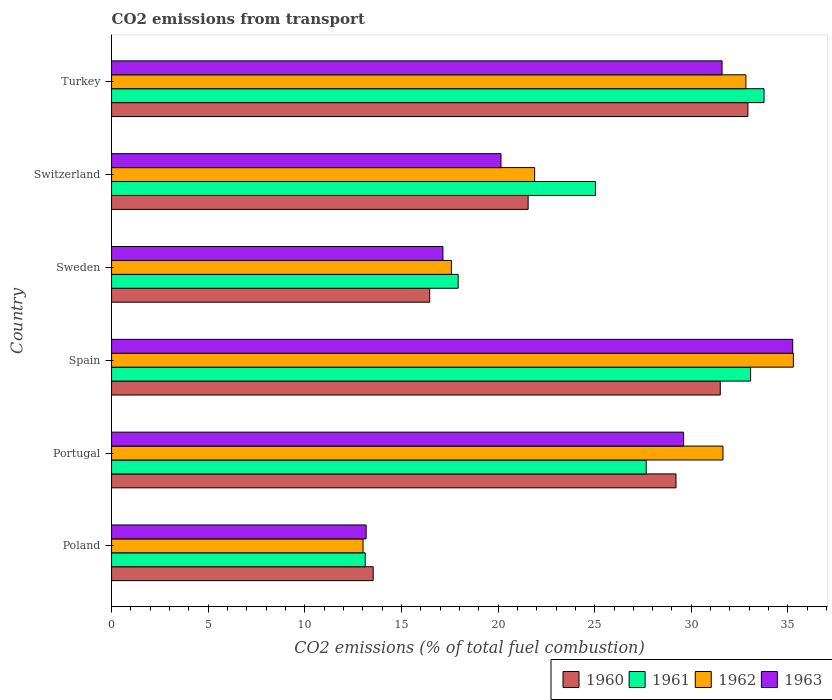How many different coloured bars are there?
Offer a very short reply. 4. Are the number of bars per tick equal to the number of legend labels?
Make the answer very short. Yes. Are the number of bars on each tick of the Y-axis equal?
Your answer should be compact. Yes. How many bars are there on the 2nd tick from the bottom?
Provide a succinct answer. 4. What is the label of the 4th group of bars from the top?
Offer a very short reply. Spain. What is the total CO2 emitted in 1960 in Sweden?
Give a very brief answer. 16.46. Across all countries, what is the maximum total CO2 emitted in 1962?
Your answer should be compact. 35.28. Across all countries, what is the minimum total CO2 emitted in 1961?
Provide a short and direct response. 13.13. What is the total total CO2 emitted in 1963 in the graph?
Give a very brief answer. 146.91. What is the difference between the total CO2 emitted in 1963 in Poland and that in Switzerland?
Your answer should be compact. -6.98. What is the difference between the total CO2 emitted in 1962 in Poland and the total CO2 emitted in 1960 in Turkey?
Provide a succinct answer. -19.91. What is the average total CO2 emitted in 1961 per country?
Your answer should be very brief. 25.1. What is the difference between the total CO2 emitted in 1961 and total CO2 emitted in 1962 in Sweden?
Make the answer very short. 0.35. In how many countries, is the total CO2 emitted in 1963 greater than 21 ?
Make the answer very short. 3. What is the ratio of the total CO2 emitted in 1961 in Poland to that in Portugal?
Provide a short and direct response. 0.47. Is the difference between the total CO2 emitted in 1961 in Portugal and Turkey greater than the difference between the total CO2 emitted in 1962 in Portugal and Turkey?
Provide a succinct answer. No. What is the difference between the highest and the second highest total CO2 emitted in 1963?
Give a very brief answer. 3.66. What is the difference between the highest and the lowest total CO2 emitted in 1960?
Provide a short and direct response. 19.39. Is the sum of the total CO2 emitted in 1960 in Poland and Portugal greater than the maximum total CO2 emitted in 1961 across all countries?
Keep it short and to the point. Yes. Is it the case that in every country, the sum of the total CO2 emitted in 1962 and total CO2 emitted in 1961 is greater than the sum of total CO2 emitted in 1963 and total CO2 emitted in 1960?
Offer a terse response. No. What does the 4th bar from the bottom in Spain represents?
Provide a short and direct response. 1963. Is it the case that in every country, the sum of the total CO2 emitted in 1963 and total CO2 emitted in 1961 is greater than the total CO2 emitted in 1962?
Your answer should be very brief. Yes. Are all the bars in the graph horizontal?
Offer a very short reply. Yes. How many countries are there in the graph?
Keep it short and to the point. 6. Does the graph contain any zero values?
Give a very brief answer. No. Where does the legend appear in the graph?
Give a very brief answer. Bottom right. How many legend labels are there?
Provide a short and direct response. 4. What is the title of the graph?
Ensure brevity in your answer.  CO2 emissions from transport. What is the label or title of the X-axis?
Offer a very short reply. CO2 emissions (% of total fuel combustion). What is the label or title of the Y-axis?
Keep it short and to the point. Country. What is the CO2 emissions (% of total fuel combustion) of 1960 in Poland?
Provide a succinct answer. 13.54. What is the CO2 emissions (% of total fuel combustion) of 1961 in Poland?
Make the answer very short. 13.13. What is the CO2 emissions (% of total fuel combustion) of 1962 in Poland?
Provide a succinct answer. 13.01. What is the CO2 emissions (% of total fuel combustion) in 1963 in Poland?
Provide a short and direct response. 13.17. What is the CO2 emissions (% of total fuel combustion) in 1960 in Portugal?
Give a very brief answer. 29.21. What is the CO2 emissions (% of total fuel combustion) of 1961 in Portugal?
Give a very brief answer. 27.67. What is the CO2 emissions (% of total fuel combustion) of 1962 in Portugal?
Provide a succinct answer. 31.64. What is the CO2 emissions (% of total fuel combustion) in 1963 in Portugal?
Provide a short and direct response. 29.6. What is the CO2 emissions (% of total fuel combustion) of 1960 in Spain?
Ensure brevity in your answer.  31.5. What is the CO2 emissions (% of total fuel combustion) of 1961 in Spain?
Offer a very short reply. 33.07. What is the CO2 emissions (% of total fuel combustion) in 1962 in Spain?
Provide a short and direct response. 35.28. What is the CO2 emissions (% of total fuel combustion) in 1963 in Spain?
Offer a very short reply. 35.25. What is the CO2 emissions (% of total fuel combustion) of 1960 in Sweden?
Your response must be concise. 16.46. What is the CO2 emissions (% of total fuel combustion) in 1961 in Sweden?
Make the answer very short. 17.94. What is the CO2 emissions (% of total fuel combustion) in 1962 in Sweden?
Your answer should be compact. 17.59. What is the CO2 emissions (% of total fuel combustion) of 1963 in Sweden?
Make the answer very short. 17.15. What is the CO2 emissions (% of total fuel combustion) in 1960 in Switzerland?
Give a very brief answer. 21.56. What is the CO2 emissions (% of total fuel combustion) in 1961 in Switzerland?
Provide a short and direct response. 25.04. What is the CO2 emissions (% of total fuel combustion) of 1962 in Switzerland?
Provide a succinct answer. 21.89. What is the CO2 emissions (% of total fuel combustion) of 1963 in Switzerland?
Make the answer very short. 20.15. What is the CO2 emissions (% of total fuel combustion) in 1960 in Turkey?
Provide a short and direct response. 32.93. What is the CO2 emissions (% of total fuel combustion) in 1961 in Turkey?
Make the answer very short. 33.76. What is the CO2 emissions (% of total fuel combustion) in 1962 in Turkey?
Provide a short and direct response. 32.82. What is the CO2 emissions (% of total fuel combustion) in 1963 in Turkey?
Give a very brief answer. 31.59. Across all countries, what is the maximum CO2 emissions (% of total fuel combustion) of 1960?
Offer a terse response. 32.93. Across all countries, what is the maximum CO2 emissions (% of total fuel combustion) of 1961?
Provide a succinct answer. 33.76. Across all countries, what is the maximum CO2 emissions (% of total fuel combustion) of 1962?
Make the answer very short. 35.28. Across all countries, what is the maximum CO2 emissions (% of total fuel combustion) in 1963?
Provide a short and direct response. 35.25. Across all countries, what is the minimum CO2 emissions (% of total fuel combustion) of 1960?
Your answer should be compact. 13.54. Across all countries, what is the minimum CO2 emissions (% of total fuel combustion) of 1961?
Give a very brief answer. 13.13. Across all countries, what is the minimum CO2 emissions (% of total fuel combustion) in 1962?
Your answer should be very brief. 13.01. Across all countries, what is the minimum CO2 emissions (% of total fuel combustion) in 1963?
Your answer should be very brief. 13.17. What is the total CO2 emissions (% of total fuel combustion) in 1960 in the graph?
Offer a very short reply. 145.19. What is the total CO2 emissions (% of total fuel combustion) of 1961 in the graph?
Give a very brief answer. 150.6. What is the total CO2 emissions (% of total fuel combustion) in 1962 in the graph?
Provide a succinct answer. 152.24. What is the total CO2 emissions (% of total fuel combustion) of 1963 in the graph?
Your answer should be very brief. 146.91. What is the difference between the CO2 emissions (% of total fuel combustion) in 1960 in Poland and that in Portugal?
Your response must be concise. -15.67. What is the difference between the CO2 emissions (% of total fuel combustion) of 1961 in Poland and that in Portugal?
Ensure brevity in your answer.  -14.54. What is the difference between the CO2 emissions (% of total fuel combustion) of 1962 in Poland and that in Portugal?
Provide a succinct answer. -18.62. What is the difference between the CO2 emissions (% of total fuel combustion) of 1963 in Poland and that in Portugal?
Make the answer very short. -16.43. What is the difference between the CO2 emissions (% of total fuel combustion) in 1960 in Poland and that in Spain?
Give a very brief answer. -17.96. What is the difference between the CO2 emissions (% of total fuel combustion) in 1961 in Poland and that in Spain?
Provide a short and direct response. -19.94. What is the difference between the CO2 emissions (% of total fuel combustion) in 1962 in Poland and that in Spain?
Your answer should be very brief. -22.27. What is the difference between the CO2 emissions (% of total fuel combustion) in 1963 in Poland and that in Spain?
Your answer should be compact. -22.07. What is the difference between the CO2 emissions (% of total fuel combustion) in 1960 in Poland and that in Sweden?
Your response must be concise. -2.92. What is the difference between the CO2 emissions (% of total fuel combustion) in 1961 in Poland and that in Sweden?
Keep it short and to the point. -4.81. What is the difference between the CO2 emissions (% of total fuel combustion) of 1962 in Poland and that in Sweden?
Give a very brief answer. -4.57. What is the difference between the CO2 emissions (% of total fuel combustion) of 1963 in Poland and that in Sweden?
Offer a very short reply. -3.97. What is the difference between the CO2 emissions (% of total fuel combustion) in 1960 in Poland and that in Switzerland?
Ensure brevity in your answer.  -8.02. What is the difference between the CO2 emissions (% of total fuel combustion) of 1961 in Poland and that in Switzerland?
Ensure brevity in your answer.  -11.91. What is the difference between the CO2 emissions (% of total fuel combustion) of 1962 in Poland and that in Switzerland?
Your answer should be compact. -8.88. What is the difference between the CO2 emissions (% of total fuel combustion) in 1963 in Poland and that in Switzerland?
Make the answer very short. -6.98. What is the difference between the CO2 emissions (% of total fuel combustion) of 1960 in Poland and that in Turkey?
Give a very brief answer. -19.39. What is the difference between the CO2 emissions (% of total fuel combustion) in 1961 in Poland and that in Turkey?
Keep it short and to the point. -20.64. What is the difference between the CO2 emissions (% of total fuel combustion) in 1962 in Poland and that in Turkey?
Provide a short and direct response. -19.81. What is the difference between the CO2 emissions (% of total fuel combustion) of 1963 in Poland and that in Turkey?
Offer a very short reply. -18.42. What is the difference between the CO2 emissions (% of total fuel combustion) in 1960 in Portugal and that in Spain?
Your answer should be compact. -2.29. What is the difference between the CO2 emissions (% of total fuel combustion) in 1961 in Portugal and that in Spain?
Your answer should be compact. -5.4. What is the difference between the CO2 emissions (% of total fuel combustion) of 1962 in Portugal and that in Spain?
Keep it short and to the point. -3.64. What is the difference between the CO2 emissions (% of total fuel combustion) in 1963 in Portugal and that in Spain?
Offer a very short reply. -5.65. What is the difference between the CO2 emissions (% of total fuel combustion) of 1960 in Portugal and that in Sweden?
Your response must be concise. 12.75. What is the difference between the CO2 emissions (% of total fuel combustion) of 1961 in Portugal and that in Sweden?
Keep it short and to the point. 9.73. What is the difference between the CO2 emissions (% of total fuel combustion) in 1962 in Portugal and that in Sweden?
Offer a very short reply. 14.05. What is the difference between the CO2 emissions (% of total fuel combustion) of 1963 in Portugal and that in Sweden?
Make the answer very short. 12.45. What is the difference between the CO2 emissions (% of total fuel combustion) of 1960 in Portugal and that in Switzerland?
Provide a succinct answer. 7.65. What is the difference between the CO2 emissions (% of total fuel combustion) in 1961 in Portugal and that in Switzerland?
Offer a very short reply. 2.62. What is the difference between the CO2 emissions (% of total fuel combustion) of 1962 in Portugal and that in Switzerland?
Provide a succinct answer. 9.75. What is the difference between the CO2 emissions (% of total fuel combustion) in 1963 in Portugal and that in Switzerland?
Give a very brief answer. 9.45. What is the difference between the CO2 emissions (% of total fuel combustion) in 1960 in Portugal and that in Turkey?
Your answer should be compact. -3.72. What is the difference between the CO2 emissions (% of total fuel combustion) in 1961 in Portugal and that in Turkey?
Keep it short and to the point. -6.1. What is the difference between the CO2 emissions (% of total fuel combustion) in 1962 in Portugal and that in Turkey?
Make the answer very short. -1.19. What is the difference between the CO2 emissions (% of total fuel combustion) in 1963 in Portugal and that in Turkey?
Provide a short and direct response. -1.99. What is the difference between the CO2 emissions (% of total fuel combustion) of 1960 in Spain and that in Sweden?
Provide a succinct answer. 15.04. What is the difference between the CO2 emissions (% of total fuel combustion) of 1961 in Spain and that in Sweden?
Offer a very short reply. 15.13. What is the difference between the CO2 emissions (% of total fuel combustion) in 1962 in Spain and that in Sweden?
Your response must be concise. 17.7. What is the difference between the CO2 emissions (% of total fuel combustion) of 1963 in Spain and that in Sweden?
Provide a short and direct response. 18.1. What is the difference between the CO2 emissions (% of total fuel combustion) in 1960 in Spain and that in Switzerland?
Keep it short and to the point. 9.94. What is the difference between the CO2 emissions (% of total fuel combustion) of 1961 in Spain and that in Switzerland?
Offer a very short reply. 8.03. What is the difference between the CO2 emissions (% of total fuel combustion) of 1962 in Spain and that in Switzerland?
Keep it short and to the point. 13.39. What is the difference between the CO2 emissions (% of total fuel combustion) of 1963 in Spain and that in Switzerland?
Your answer should be compact. 15.1. What is the difference between the CO2 emissions (% of total fuel combustion) of 1960 in Spain and that in Turkey?
Your answer should be compact. -1.43. What is the difference between the CO2 emissions (% of total fuel combustion) in 1961 in Spain and that in Turkey?
Offer a terse response. -0.7. What is the difference between the CO2 emissions (% of total fuel combustion) of 1962 in Spain and that in Turkey?
Keep it short and to the point. 2.46. What is the difference between the CO2 emissions (% of total fuel combustion) in 1963 in Spain and that in Turkey?
Offer a very short reply. 3.66. What is the difference between the CO2 emissions (% of total fuel combustion) in 1960 in Sweden and that in Switzerland?
Provide a short and direct response. -5.09. What is the difference between the CO2 emissions (% of total fuel combustion) of 1961 in Sweden and that in Switzerland?
Give a very brief answer. -7.1. What is the difference between the CO2 emissions (% of total fuel combustion) of 1962 in Sweden and that in Switzerland?
Ensure brevity in your answer.  -4.31. What is the difference between the CO2 emissions (% of total fuel combustion) in 1963 in Sweden and that in Switzerland?
Provide a succinct answer. -3.01. What is the difference between the CO2 emissions (% of total fuel combustion) of 1960 in Sweden and that in Turkey?
Provide a short and direct response. -16.47. What is the difference between the CO2 emissions (% of total fuel combustion) of 1961 in Sweden and that in Turkey?
Your answer should be very brief. -15.83. What is the difference between the CO2 emissions (% of total fuel combustion) of 1962 in Sweden and that in Turkey?
Your response must be concise. -15.24. What is the difference between the CO2 emissions (% of total fuel combustion) in 1963 in Sweden and that in Turkey?
Ensure brevity in your answer.  -14.44. What is the difference between the CO2 emissions (% of total fuel combustion) of 1960 in Switzerland and that in Turkey?
Your answer should be very brief. -11.37. What is the difference between the CO2 emissions (% of total fuel combustion) of 1961 in Switzerland and that in Turkey?
Provide a succinct answer. -8.72. What is the difference between the CO2 emissions (% of total fuel combustion) in 1962 in Switzerland and that in Turkey?
Ensure brevity in your answer.  -10.93. What is the difference between the CO2 emissions (% of total fuel combustion) of 1963 in Switzerland and that in Turkey?
Provide a succinct answer. -11.44. What is the difference between the CO2 emissions (% of total fuel combustion) of 1960 in Poland and the CO2 emissions (% of total fuel combustion) of 1961 in Portugal?
Provide a succinct answer. -14.13. What is the difference between the CO2 emissions (% of total fuel combustion) of 1960 in Poland and the CO2 emissions (% of total fuel combustion) of 1962 in Portugal?
Your answer should be very brief. -18.1. What is the difference between the CO2 emissions (% of total fuel combustion) in 1960 in Poland and the CO2 emissions (% of total fuel combustion) in 1963 in Portugal?
Keep it short and to the point. -16.06. What is the difference between the CO2 emissions (% of total fuel combustion) of 1961 in Poland and the CO2 emissions (% of total fuel combustion) of 1962 in Portugal?
Your answer should be very brief. -18.51. What is the difference between the CO2 emissions (% of total fuel combustion) of 1961 in Poland and the CO2 emissions (% of total fuel combustion) of 1963 in Portugal?
Give a very brief answer. -16.47. What is the difference between the CO2 emissions (% of total fuel combustion) of 1962 in Poland and the CO2 emissions (% of total fuel combustion) of 1963 in Portugal?
Give a very brief answer. -16.59. What is the difference between the CO2 emissions (% of total fuel combustion) in 1960 in Poland and the CO2 emissions (% of total fuel combustion) in 1961 in Spain?
Provide a succinct answer. -19.53. What is the difference between the CO2 emissions (% of total fuel combustion) in 1960 in Poland and the CO2 emissions (% of total fuel combustion) in 1962 in Spain?
Your answer should be very brief. -21.75. What is the difference between the CO2 emissions (% of total fuel combustion) of 1960 in Poland and the CO2 emissions (% of total fuel combustion) of 1963 in Spain?
Ensure brevity in your answer.  -21.71. What is the difference between the CO2 emissions (% of total fuel combustion) of 1961 in Poland and the CO2 emissions (% of total fuel combustion) of 1962 in Spain?
Your response must be concise. -22.16. What is the difference between the CO2 emissions (% of total fuel combustion) of 1961 in Poland and the CO2 emissions (% of total fuel combustion) of 1963 in Spain?
Provide a succinct answer. -22.12. What is the difference between the CO2 emissions (% of total fuel combustion) in 1962 in Poland and the CO2 emissions (% of total fuel combustion) in 1963 in Spain?
Provide a succinct answer. -22.23. What is the difference between the CO2 emissions (% of total fuel combustion) in 1960 in Poland and the CO2 emissions (% of total fuel combustion) in 1961 in Sweden?
Make the answer very short. -4.4. What is the difference between the CO2 emissions (% of total fuel combustion) of 1960 in Poland and the CO2 emissions (% of total fuel combustion) of 1962 in Sweden?
Ensure brevity in your answer.  -4.05. What is the difference between the CO2 emissions (% of total fuel combustion) in 1960 in Poland and the CO2 emissions (% of total fuel combustion) in 1963 in Sweden?
Provide a succinct answer. -3.61. What is the difference between the CO2 emissions (% of total fuel combustion) in 1961 in Poland and the CO2 emissions (% of total fuel combustion) in 1962 in Sweden?
Your answer should be compact. -4.46. What is the difference between the CO2 emissions (% of total fuel combustion) of 1961 in Poland and the CO2 emissions (% of total fuel combustion) of 1963 in Sweden?
Give a very brief answer. -4.02. What is the difference between the CO2 emissions (% of total fuel combustion) in 1962 in Poland and the CO2 emissions (% of total fuel combustion) in 1963 in Sweden?
Offer a very short reply. -4.13. What is the difference between the CO2 emissions (% of total fuel combustion) of 1960 in Poland and the CO2 emissions (% of total fuel combustion) of 1961 in Switzerland?
Provide a succinct answer. -11.5. What is the difference between the CO2 emissions (% of total fuel combustion) of 1960 in Poland and the CO2 emissions (% of total fuel combustion) of 1962 in Switzerland?
Offer a terse response. -8.36. What is the difference between the CO2 emissions (% of total fuel combustion) in 1960 in Poland and the CO2 emissions (% of total fuel combustion) in 1963 in Switzerland?
Offer a terse response. -6.61. What is the difference between the CO2 emissions (% of total fuel combustion) of 1961 in Poland and the CO2 emissions (% of total fuel combustion) of 1962 in Switzerland?
Make the answer very short. -8.77. What is the difference between the CO2 emissions (% of total fuel combustion) of 1961 in Poland and the CO2 emissions (% of total fuel combustion) of 1963 in Switzerland?
Your response must be concise. -7.02. What is the difference between the CO2 emissions (% of total fuel combustion) in 1962 in Poland and the CO2 emissions (% of total fuel combustion) in 1963 in Switzerland?
Keep it short and to the point. -7.14. What is the difference between the CO2 emissions (% of total fuel combustion) of 1960 in Poland and the CO2 emissions (% of total fuel combustion) of 1961 in Turkey?
Ensure brevity in your answer.  -20.23. What is the difference between the CO2 emissions (% of total fuel combustion) of 1960 in Poland and the CO2 emissions (% of total fuel combustion) of 1962 in Turkey?
Your response must be concise. -19.29. What is the difference between the CO2 emissions (% of total fuel combustion) of 1960 in Poland and the CO2 emissions (% of total fuel combustion) of 1963 in Turkey?
Offer a terse response. -18.05. What is the difference between the CO2 emissions (% of total fuel combustion) in 1961 in Poland and the CO2 emissions (% of total fuel combustion) in 1962 in Turkey?
Give a very brief answer. -19.7. What is the difference between the CO2 emissions (% of total fuel combustion) of 1961 in Poland and the CO2 emissions (% of total fuel combustion) of 1963 in Turkey?
Offer a very short reply. -18.46. What is the difference between the CO2 emissions (% of total fuel combustion) in 1962 in Poland and the CO2 emissions (% of total fuel combustion) in 1963 in Turkey?
Offer a very short reply. -18.58. What is the difference between the CO2 emissions (% of total fuel combustion) of 1960 in Portugal and the CO2 emissions (% of total fuel combustion) of 1961 in Spain?
Ensure brevity in your answer.  -3.86. What is the difference between the CO2 emissions (% of total fuel combustion) in 1960 in Portugal and the CO2 emissions (% of total fuel combustion) in 1962 in Spain?
Provide a short and direct response. -6.08. What is the difference between the CO2 emissions (% of total fuel combustion) in 1960 in Portugal and the CO2 emissions (% of total fuel combustion) in 1963 in Spain?
Give a very brief answer. -6.04. What is the difference between the CO2 emissions (% of total fuel combustion) of 1961 in Portugal and the CO2 emissions (% of total fuel combustion) of 1962 in Spain?
Make the answer very short. -7.62. What is the difference between the CO2 emissions (% of total fuel combustion) in 1961 in Portugal and the CO2 emissions (% of total fuel combustion) in 1963 in Spain?
Keep it short and to the point. -7.58. What is the difference between the CO2 emissions (% of total fuel combustion) in 1962 in Portugal and the CO2 emissions (% of total fuel combustion) in 1963 in Spain?
Your answer should be very brief. -3.61. What is the difference between the CO2 emissions (% of total fuel combustion) in 1960 in Portugal and the CO2 emissions (% of total fuel combustion) in 1961 in Sweden?
Your answer should be compact. 11.27. What is the difference between the CO2 emissions (% of total fuel combustion) of 1960 in Portugal and the CO2 emissions (% of total fuel combustion) of 1962 in Sweden?
Your response must be concise. 11.62. What is the difference between the CO2 emissions (% of total fuel combustion) in 1960 in Portugal and the CO2 emissions (% of total fuel combustion) in 1963 in Sweden?
Make the answer very short. 12.06. What is the difference between the CO2 emissions (% of total fuel combustion) in 1961 in Portugal and the CO2 emissions (% of total fuel combustion) in 1962 in Sweden?
Your response must be concise. 10.08. What is the difference between the CO2 emissions (% of total fuel combustion) of 1961 in Portugal and the CO2 emissions (% of total fuel combustion) of 1963 in Sweden?
Your answer should be compact. 10.52. What is the difference between the CO2 emissions (% of total fuel combustion) in 1962 in Portugal and the CO2 emissions (% of total fuel combustion) in 1963 in Sweden?
Your response must be concise. 14.49. What is the difference between the CO2 emissions (% of total fuel combustion) of 1960 in Portugal and the CO2 emissions (% of total fuel combustion) of 1961 in Switzerland?
Your answer should be compact. 4.17. What is the difference between the CO2 emissions (% of total fuel combustion) in 1960 in Portugal and the CO2 emissions (% of total fuel combustion) in 1962 in Switzerland?
Provide a succinct answer. 7.32. What is the difference between the CO2 emissions (% of total fuel combustion) of 1960 in Portugal and the CO2 emissions (% of total fuel combustion) of 1963 in Switzerland?
Your response must be concise. 9.06. What is the difference between the CO2 emissions (% of total fuel combustion) in 1961 in Portugal and the CO2 emissions (% of total fuel combustion) in 1962 in Switzerland?
Your answer should be compact. 5.77. What is the difference between the CO2 emissions (% of total fuel combustion) of 1961 in Portugal and the CO2 emissions (% of total fuel combustion) of 1963 in Switzerland?
Offer a terse response. 7.51. What is the difference between the CO2 emissions (% of total fuel combustion) of 1962 in Portugal and the CO2 emissions (% of total fuel combustion) of 1963 in Switzerland?
Ensure brevity in your answer.  11.49. What is the difference between the CO2 emissions (% of total fuel combustion) in 1960 in Portugal and the CO2 emissions (% of total fuel combustion) in 1961 in Turkey?
Make the answer very short. -4.56. What is the difference between the CO2 emissions (% of total fuel combustion) of 1960 in Portugal and the CO2 emissions (% of total fuel combustion) of 1962 in Turkey?
Provide a short and direct response. -3.62. What is the difference between the CO2 emissions (% of total fuel combustion) in 1960 in Portugal and the CO2 emissions (% of total fuel combustion) in 1963 in Turkey?
Keep it short and to the point. -2.38. What is the difference between the CO2 emissions (% of total fuel combustion) in 1961 in Portugal and the CO2 emissions (% of total fuel combustion) in 1962 in Turkey?
Provide a succinct answer. -5.16. What is the difference between the CO2 emissions (% of total fuel combustion) of 1961 in Portugal and the CO2 emissions (% of total fuel combustion) of 1963 in Turkey?
Make the answer very short. -3.93. What is the difference between the CO2 emissions (% of total fuel combustion) of 1962 in Portugal and the CO2 emissions (% of total fuel combustion) of 1963 in Turkey?
Your answer should be very brief. 0.05. What is the difference between the CO2 emissions (% of total fuel combustion) of 1960 in Spain and the CO2 emissions (% of total fuel combustion) of 1961 in Sweden?
Ensure brevity in your answer.  13.56. What is the difference between the CO2 emissions (% of total fuel combustion) of 1960 in Spain and the CO2 emissions (% of total fuel combustion) of 1962 in Sweden?
Ensure brevity in your answer.  13.91. What is the difference between the CO2 emissions (% of total fuel combustion) of 1960 in Spain and the CO2 emissions (% of total fuel combustion) of 1963 in Sweden?
Offer a very short reply. 14.35. What is the difference between the CO2 emissions (% of total fuel combustion) in 1961 in Spain and the CO2 emissions (% of total fuel combustion) in 1962 in Sweden?
Your response must be concise. 15.48. What is the difference between the CO2 emissions (% of total fuel combustion) of 1961 in Spain and the CO2 emissions (% of total fuel combustion) of 1963 in Sweden?
Your answer should be very brief. 15.92. What is the difference between the CO2 emissions (% of total fuel combustion) in 1962 in Spain and the CO2 emissions (% of total fuel combustion) in 1963 in Sweden?
Provide a short and direct response. 18.14. What is the difference between the CO2 emissions (% of total fuel combustion) in 1960 in Spain and the CO2 emissions (% of total fuel combustion) in 1961 in Switzerland?
Your response must be concise. 6.46. What is the difference between the CO2 emissions (% of total fuel combustion) of 1960 in Spain and the CO2 emissions (% of total fuel combustion) of 1962 in Switzerland?
Ensure brevity in your answer.  9.61. What is the difference between the CO2 emissions (% of total fuel combustion) in 1960 in Spain and the CO2 emissions (% of total fuel combustion) in 1963 in Switzerland?
Offer a very short reply. 11.35. What is the difference between the CO2 emissions (% of total fuel combustion) of 1961 in Spain and the CO2 emissions (% of total fuel combustion) of 1962 in Switzerland?
Make the answer very short. 11.17. What is the difference between the CO2 emissions (% of total fuel combustion) of 1961 in Spain and the CO2 emissions (% of total fuel combustion) of 1963 in Switzerland?
Your answer should be compact. 12.92. What is the difference between the CO2 emissions (% of total fuel combustion) in 1962 in Spain and the CO2 emissions (% of total fuel combustion) in 1963 in Switzerland?
Your answer should be very brief. 15.13. What is the difference between the CO2 emissions (% of total fuel combustion) in 1960 in Spain and the CO2 emissions (% of total fuel combustion) in 1961 in Turkey?
Your response must be concise. -2.27. What is the difference between the CO2 emissions (% of total fuel combustion) of 1960 in Spain and the CO2 emissions (% of total fuel combustion) of 1962 in Turkey?
Your answer should be very brief. -1.33. What is the difference between the CO2 emissions (% of total fuel combustion) in 1960 in Spain and the CO2 emissions (% of total fuel combustion) in 1963 in Turkey?
Provide a short and direct response. -0.09. What is the difference between the CO2 emissions (% of total fuel combustion) in 1961 in Spain and the CO2 emissions (% of total fuel combustion) in 1962 in Turkey?
Offer a terse response. 0.24. What is the difference between the CO2 emissions (% of total fuel combustion) in 1961 in Spain and the CO2 emissions (% of total fuel combustion) in 1963 in Turkey?
Provide a short and direct response. 1.48. What is the difference between the CO2 emissions (% of total fuel combustion) of 1962 in Spain and the CO2 emissions (% of total fuel combustion) of 1963 in Turkey?
Give a very brief answer. 3.69. What is the difference between the CO2 emissions (% of total fuel combustion) in 1960 in Sweden and the CO2 emissions (% of total fuel combustion) in 1961 in Switzerland?
Offer a terse response. -8.58. What is the difference between the CO2 emissions (% of total fuel combustion) of 1960 in Sweden and the CO2 emissions (% of total fuel combustion) of 1962 in Switzerland?
Provide a short and direct response. -5.43. What is the difference between the CO2 emissions (% of total fuel combustion) of 1960 in Sweden and the CO2 emissions (% of total fuel combustion) of 1963 in Switzerland?
Keep it short and to the point. -3.69. What is the difference between the CO2 emissions (% of total fuel combustion) of 1961 in Sweden and the CO2 emissions (% of total fuel combustion) of 1962 in Switzerland?
Make the answer very short. -3.96. What is the difference between the CO2 emissions (% of total fuel combustion) in 1961 in Sweden and the CO2 emissions (% of total fuel combustion) in 1963 in Switzerland?
Keep it short and to the point. -2.22. What is the difference between the CO2 emissions (% of total fuel combustion) in 1962 in Sweden and the CO2 emissions (% of total fuel combustion) in 1963 in Switzerland?
Your response must be concise. -2.57. What is the difference between the CO2 emissions (% of total fuel combustion) in 1960 in Sweden and the CO2 emissions (% of total fuel combustion) in 1961 in Turkey?
Your answer should be very brief. -17.3. What is the difference between the CO2 emissions (% of total fuel combustion) of 1960 in Sweden and the CO2 emissions (% of total fuel combustion) of 1962 in Turkey?
Your answer should be very brief. -16.36. What is the difference between the CO2 emissions (% of total fuel combustion) in 1960 in Sweden and the CO2 emissions (% of total fuel combustion) in 1963 in Turkey?
Keep it short and to the point. -15.13. What is the difference between the CO2 emissions (% of total fuel combustion) of 1961 in Sweden and the CO2 emissions (% of total fuel combustion) of 1962 in Turkey?
Keep it short and to the point. -14.89. What is the difference between the CO2 emissions (% of total fuel combustion) of 1961 in Sweden and the CO2 emissions (% of total fuel combustion) of 1963 in Turkey?
Your answer should be compact. -13.66. What is the difference between the CO2 emissions (% of total fuel combustion) in 1962 in Sweden and the CO2 emissions (% of total fuel combustion) in 1963 in Turkey?
Your answer should be compact. -14.01. What is the difference between the CO2 emissions (% of total fuel combustion) of 1960 in Switzerland and the CO2 emissions (% of total fuel combustion) of 1961 in Turkey?
Ensure brevity in your answer.  -12.21. What is the difference between the CO2 emissions (% of total fuel combustion) of 1960 in Switzerland and the CO2 emissions (% of total fuel combustion) of 1962 in Turkey?
Provide a short and direct response. -11.27. What is the difference between the CO2 emissions (% of total fuel combustion) of 1960 in Switzerland and the CO2 emissions (% of total fuel combustion) of 1963 in Turkey?
Offer a very short reply. -10.04. What is the difference between the CO2 emissions (% of total fuel combustion) of 1961 in Switzerland and the CO2 emissions (% of total fuel combustion) of 1962 in Turkey?
Give a very brief answer. -7.78. What is the difference between the CO2 emissions (% of total fuel combustion) in 1961 in Switzerland and the CO2 emissions (% of total fuel combustion) in 1963 in Turkey?
Your response must be concise. -6.55. What is the difference between the CO2 emissions (% of total fuel combustion) in 1962 in Switzerland and the CO2 emissions (% of total fuel combustion) in 1963 in Turkey?
Offer a very short reply. -9.7. What is the average CO2 emissions (% of total fuel combustion) in 1960 per country?
Offer a terse response. 24.2. What is the average CO2 emissions (% of total fuel combustion) of 1961 per country?
Your answer should be very brief. 25.1. What is the average CO2 emissions (% of total fuel combustion) of 1962 per country?
Your response must be concise. 25.37. What is the average CO2 emissions (% of total fuel combustion) of 1963 per country?
Provide a succinct answer. 24.49. What is the difference between the CO2 emissions (% of total fuel combustion) of 1960 and CO2 emissions (% of total fuel combustion) of 1961 in Poland?
Your response must be concise. 0.41. What is the difference between the CO2 emissions (% of total fuel combustion) in 1960 and CO2 emissions (% of total fuel combustion) in 1962 in Poland?
Keep it short and to the point. 0.52. What is the difference between the CO2 emissions (% of total fuel combustion) of 1960 and CO2 emissions (% of total fuel combustion) of 1963 in Poland?
Your response must be concise. 0.36. What is the difference between the CO2 emissions (% of total fuel combustion) in 1961 and CO2 emissions (% of total fuel combustion) in 1962 in Poland?
Your answer should be compact. 0.11. What is the difference between the CO2 emissions (% of total fuel combustion) of 1961 and CO2 emissions (% of total fuel combustion) of 1963 in Poland?
Ensure brevity in your answer.  -0.05. What is the difference between the CO2 emissions (% of total fuel combustion) of 1962 and CO2 emissions (% of total fuel combustion) of 1963 in Poland?
Ensure brevity in your answer.  -0.16. What is the difference between the CO2 emissions (% of total fuel combustion) of 1960 and CO2 emissions (% of total fuel combustion) of 1961 in Portugal?
Make the answer very short. 1.54. What is the difference between the CO2 emissions (% of total fuel combustion) in 1960 and CO2 emissions (% of total fuel combustion) in 1962 in Portugal?
Provide a succinct answer. -2.43. What is the difference between the CO2 emissions (% of total fuel combustion) in 1960 and CO2 emissions (% of total fuel combustion) in 1963 in Portugal?
Offer a very short reply. -0.39. What is the difference between the CO2 emissions (% of total fuel combustion) of 1961 and CO2 emissions (% of total fuel combustion) of 1962 in Portugal?
Ensure brevity in your answer.  -3.97. What is the difference between the CO2 emissions (% of total fuel combustion) in 1961 and CO2 emissions (% of total fuel combustion) in 1963 in Portugal?
Your response must be concise. -1.94. What is the difference between the CO2 emissions (% of total fuel combustion) in 1962 and CO2 emissions (% of total fuel combustion) in 1963 in Portugal?
Give a very brief answer. 2.04. What is the difference between the CO2 emissions (% of total fuel combustion) of 1960 and CO2 emissions (% of total fuel combustion) of 1961 in Spain?
Provide a succinct answer. -1.57. What is the difference between the CO2 emissions (% of total fuel combustion) in 1960 and CO2 emissions (% of total fuel combustion) in 1962 in Spain?
Offer a very short reply. -3.78. What is the difference between the CO2 emissions (% of total fuel combustion) of 1960 and CO2 emissions (% of total fuel combustion) of 1963 in Spain?
Make the answer very short. -3.75. What is the difference between the CO2 emissions (% of total fuel combustion) in 1961 and CO2 emissions (% of total fuel combustion) in 1962 in Spain?
Offer a terse response. -2.22. What is the difference between the CO2 emissions (% of total fuel combustion) in 1961 and CO2 emissions (% of total fuel combustion) in 1963 in Spain?
Keep it short and to the point. -2.18. What is the difference between the CO2 emissions (% of total fuel combustion) of 1962 and CO2 emissions (% of total fuel combustion) of 1963 in Spain?
Make the answer very short. 0.04. What is the difference between the CO2 emissions (% of total fuel combustion) of 1960 and CO2 emissions (% of total fuel combustion) of 1961 in Sweden?
Your response must be concise. -1.47. What is the difference between the CO2 emissions (% of total fuel combustion) of 1960 and CO2 emissions (% of total fuel combustion) of 1962 in Sweden?
Your response must be concise. -1.12. What is the difference between the CO2 emissions (% of total fuel combustion) in 1960 and CO2 emissions (% of total fuel combustion) in 1963 in Sweden?
Give a very brief answer. -0.69. What is the difference between the CO2 emissions (% of total fuel combustion) of 1961 and CO2 emissions (% of total fuel combustion) of 1962 in Sweden?
Your response must be concise. 0.35. What is the difference between the CO2 emissions (% of total fuel combustion) of 1961 and CO2 emissions (% of total fuel combustion) of 1963 in Sweden?
Your response must be concise. 0.79. What is the difference between the CO2 emissions (% of total fuel combustion) in 1962 and CO2 emissions (% of total fuel combustion) in 1963 in Sweden?
Your answer should be compact. 0.44. What is the difference between the CO2 emissions (% of total fuel combustion) of 1960 and CO2 emissions (% of total fuel combustion) of 1961 in Switzerland?
Your response must be concise. -3.48. What is the difference between the CO2 emissions (% of total fuel combustion) of 1960 and CO2 emissions (% of total fuel combustion) of 1962 in Switzerland?
Your answer should be compact. -0.34. What is the difference between the CO2 emissions (% of total fuel combustion) of 1960 and CO2 emissions (% of total fuel combustion) of 1963 in Switzerland?
Ensure brevity in your answer.  1.4. What is the difference between the CO2 emissions (% of total fuel combustion) in 1961 and CO2 emissions (% of total fuel combustion) in 1962 in Switzerland?
Offer a terse response. 3.15. What is the difference between the CO2 emissions (% of total fuel combustion) of 1961 and CO2 emissions (% of total fuel combustion) of 1963 in Switzerland?
Offer a very short reply. 4.89. What is the difference between the CO2 emissions (% of total fuel combustion) in 1962 and CO2 emissions (% of total fuel combustion) in 1963 in Switzerland?
Ensure brevity in your answer.  1.74. What is the difference between the CO2 emissions (% of total fuel combustion) of 1960 and CO2 emissions (% of total fuel combustion) of 1961 in Turkey?
Offer a very short reply. -0.84. What is the difference between the CO2 emissions (% of total fuel combustion) in 1960 and CO2 emissions (% of total fuel combustion) in 1962 in Turkey?
Give a very brief answer. 0.1. What is the difference between the CO2 emissions (% of total fuel combustion) of 1960 and CO2 emissions (% of total fuel combustion) of 1963 in Turkey?
Give a very brief answer. 1.34. What is the difference between the CO2 emissions (% of total fuel combustion) in 1961 and CO2 emissions (% of total fuel combustion) in 1962 in Turkey?
Offer a very short reply. 0.94. What is the difference between the CO2 emissions (% of total fuel combustion) in 1961 and CO2 emissions (% of total fuel combustion) in 1963 in Turkey?
Provide a succinct answer. 2.17. What is the difference between the CO2 emissions (% of total fuel combustion) in 1962 and CO2 emissions (% of total fuel combustion) in 1963 in Turkey?
Ensure brevity in your answer.  1.23. What is the ratio of the CO2 emissions (% of total fuel combustion) in 1960 in Poland to that in Portugal?
Offer a terse response. 0.46. What is the ratio of the CO2 emissions (% of total fuel combustion) of 1961 in Poland to that in Portugal?
Give a very brief answer. 0.47. What is the ratio of the CO2 emissions (% of total fuel combustion) of 1962 in Poland to that in Portugal?
Offer a terse response. 0.41. What is the ratio of the CO2 emissions (% of total fuel combustion) in 1963 in Poland to that in Portugal?
Provide a short and direct response. 0.45. What is the ratio of the CO2 emissions (% of total fuel combustion) of 1960 in Poland to that in Spain?
Ensure brevity in your answer.  0.43. What is the ratio of the CO2 emissions (% of total fuel combustion) in 1961 in Poland to that in Spain?
Ensure brevity in your answer.  0.4. What is the ratio of the CO2 emissions (% of total fuel combustion) in 1962 in Poland to that in Spain?
Your response must be concise. 0.37. What is the ratio of the CO2 emissions (% of total fuel combustion) of 1963 in Poland to that in Spain?
Your answer should be very brief. 0.37. What is the ratio of the CO2 emissions (% of total fuel combustion) in 1960 in Poland to that in Sweden?
Offer a very short reply. 0.82. What is the ratio of the CO2 emissions (% of total fuel combustion) in 1961 in Poland to that in Sweden?
Offer a very short reply. 0.73. What is the ratio of the CO2 emissions (% of total fuel combustion) in 1962 in Poland to that in Sweden?
Your response must be concise. 0.74. What is the ratio of the CO2 emissions (% of total fuel combustion) of 1963 in Poland to that in Sweden?
Your response must be concise. 0.77. What is the ratio of the CO2 emissions (% of total fuel combustion) of 1960 in Poland to that in Switzerland?
Provide a succinct answer. 0.63. What is the ratio of the CO2 emissions (% of total fuel combustion) of 1961 in Poland to that in Switzerland?
Give a very brief answer. 0.52. What is the ratio of the CO2 emissions (% of total fuel combustion) in 1962 in Poland to that in Switzerland?
Keep it short and to the point. 0.59. What is the ratio of the CO2 emissions (% of total fuel combustion) in 1963 in Poland to that in Switzerland?
Make the answer very short. 0.65. What is the ratio of the CO2 emissions (% of total fuel combustion) of 1960 in Poland to that in Turkey?
Provide a short and direct response. 0.41. What is the ratio of the CO2 emissions (% of total fuel combustion) of 1961 in Poland to that in Turkey?
Your answer should be very brief. 0.39. What is the ratio of the CO2 emissions (% of total fuel combustion) in 1962 in Poland to that in Turkey?
Your answer should be very brief. 0.4. What is the ratio of the CO2 emissions (% of total fuel combustion) in 1963 in Poland to that in Turkey?
Your answer should be very brief. 0.42. What is the ratio of the CO2 emissions (% of total fuel combustion) of 1960 in Portugal to that in Spain?
Provide a succinct answer. 0.93. What is the ratio of the CO2 emissions (% of total fuel combustion) in 1961 in Portugal to that in Spain?
Make the answer very short. 0.84. What is the ratio of the CO2 emissions (% of total fuel combustion) in 1962 in Portugal to that in Spain?
Offer a very short reply. 0.9. What is the ratio of the CO2 emissions (% of total fuel combustion) in 1963 in Portugal to that in Spain?
Offer a terse response. 0.84. What is the ratio of the CO2 emissions (% of total fuel combustion) of 1960 in Portugal to that in Sweden?
Provide a succinct answer. 1.77. What is the ratio of the CO2 emissions (% of total fuel combustion) in 1961 in Portugal to that in Sweden?
Make the answer very short. 1.54. What is the ratio of the CO2 emissions (% of total fuel combustion) of 1962 in Portugal to that in Sweden?
Offer a very short reply. 1.8. What is the ratio of the CO2 emissions (% of total fuel combustion) of 1963 in Portugal to that in Sweden?
Ensure brevity in your answer.  1.73. What is the ratio of the CO2 emissions (% of total fuel combustion) in 1960 in Portugal to that in Switzerland?
Your answer should be compact. 1.35. What is the ratio of the CO2 emissions (% of total fuel combustion) of 1961 in Portugal to that in Switzerland?
Offer a very short reply. 1.1. What is the ratio of the CO2 emissions (% of total fuel combustion) in 1962 in Portugal to that in Switzerland?
Offer a very short reply. 1.45. What is the ratio of the CO2 emissions (% of total fuel combustion) in 1963 in Portugal to that in Switzerland?
Offer a terse response. 1.47. What is the ratio of the CO2 emissions (% of total fuel combustion) in 1960 in Portugal to that in Turkey?
Your answer should be compact. 0.89. What is the ratio of the CO2 emissions (% of total fuel combustion) in 1961 in Portugal to that in Turkey?
Keep it short and to the point. 0.82. What is the ratio of the CO2 emissions (% of total fuel combustion) in 1962 in Portugal to that in Turkey?
Your answer should be compact. 0.96. What is the ratio of the CO2 emissions (% of total fuel combustion) in 1963 in Portugal to that in Turkey?
Keep it short and to the point. 0.94. What is the ratio of the CO2 emissions (% of total fuel combustion) of 1960 in Spain to that in Sweden?
Offer a very short reply. 1.91. What is the ratio of the CO2 emissions (% of total fuel combustion) of 1961 in Spain to that in Sweden?
Ensure brevity in your answer.  1.84. What is the ratio of the CO2 emissions (% of total fuel combustion) in 1962 in Spain to that in Sweden?
Your answer should be very brief. 2.01. What is the ratio of the CO2 emissions (% of total fuel combustion) of 1963 in Spain to that in Sweden?
Provide a short and direct response. 2.06. What is the ratio of the CO2 emissions (% of total fuel combustion) in 1960 in Spain to that in Switzerland?
Ensure brevity in your answer.  1.46. What is the ratio of the CO2 emissions (% of total fuel combustion) in 1961 in Spain to that in Switzerland?
Provide a short and direct response. 1.32. What is the ratio of the CO2 emissions (% of total fuel combustion) of 1962 in Spain to that in Switzerland?
Provide a succinct answer. 1.61. What is the ratio of the CO2 emissions (% of total fuel combustion) of 1963 in Spain to that in Switzerland?
Your answer should be compact. 1.75. What is the ratio of the CO2 emissions (% of total fuel combustion) of 1960 in Spain to that in Turkey?
Keep it short and to the point. 0.96. What is the ratio of the CO2 emissions (% of total fuel combustion) in 1961 in Spain to that in Turkey?
Offer a very short reply. 0.98. What is the ratio of the CO2 emissions (% of total fuel combustion) in 1962 in Spain to that in Turkey?
Offer a terse response. 1.07. What is the ratio of the CO2 emissions (% of total fuel combustion) of 1963 in Spain to that in Turkey?
Your answer should be very brief. 1.12. What is the ratio of the CO2 emissions (% of total fuel combustion) of 1960 in Sweden to that in Switzerland?
Your answer should be very brief. 0.76. What is the ratio of the CO2 emissions (% of total fuel combustion) in 1961 in Sweden to that in Switzerland?
Provide a short and direct response. 0.72. What is the ratio of the CO2 emissions (% of total fuel combustion) in 1962 in Sweden to that in Switzerland?
Provide a short and direct response. 0.8. What is the ratio of the CO2 emissions (% of total fuel combustion) in 1963 in Sweden to that in Switzerland?
Keep it short and to the point. 0.85. What is the ratio of the CO2 emissions (% of total fuel combustion) of 1960 in Sweden to that in Turkey?
Make the answer very short. 0.5. What is the ratio of the CO2 emissions (% of total fuel combustion) in 1961 in Sweden to that in Turkey?
Keep it short and to the point. 0.53. What is the ratio of the CO2 emissions (% of total fuel combustion) of 1962 in Sweden to that in Turkey?
Provide a short and direct response. 0.54. What is the ratio of the CO2 emissions (% of total fuel combustion) in 1963 in Sweden to that in Turkey?
Provide a short and direct response. 0.54. What is the ratio of the CO2 emissions (% of total fuel combustion) of 1960 in Switzerland to that in Turkey?
Your answer should be compact. 0.65. What is the ratio of the CO2 emissions (% of total fuel combustion) of 1961 in Switzerland to that in Turkey?
Your response must be concise. 0.74. What is the ratio of the CO2 emissions (% of total fuel combustion) of 1962 in Switzerland to that in Turkey?
Provide a short and direct response. 0.67. What is the ratio of the CO2 emissions (% of total fuel combustion) in 1963 in Switzerland to that in Turkey?
Your response must be concise. 0.64. What is the difference between the highest and the second highest CO2 emissions (% of total fuel combustion) in 1960?
Keep it short and to the point. 1.43. What is the difference between the highest and the second highest CO2 emissions (% of total fuel combustion) of 1961?
Your response must be concise. 0.7. What is the difference between the highest and the second highest CO2 emissions (% of total fuel combustion) in 1962?
Give a very brief answer. 2.46. What is the difference between the highest and the second highest CO2 emissions (% of total fuel combustion) in 1963?
Your answer should be very brief. 3.66. What is the difference between the highest and the lowest CO2 emissions (% of total fuel combustion) of 1960?
Your answer should be compact. 19.39. What is the difference between the highest and the lowest CO2 emissions (% of total fuel combustion) in 1961?
Keep it short and to the point. 20.64. What is the difference between the highest and the lowest CO2 emissions (% of total fuel combustion) in 1962?
Offer a terse response. 22.27. What is the difference between the highest and the lowest CO2 emissions (% of total fuel combustion) in 1963?
Your response must be concise. 22.07. 